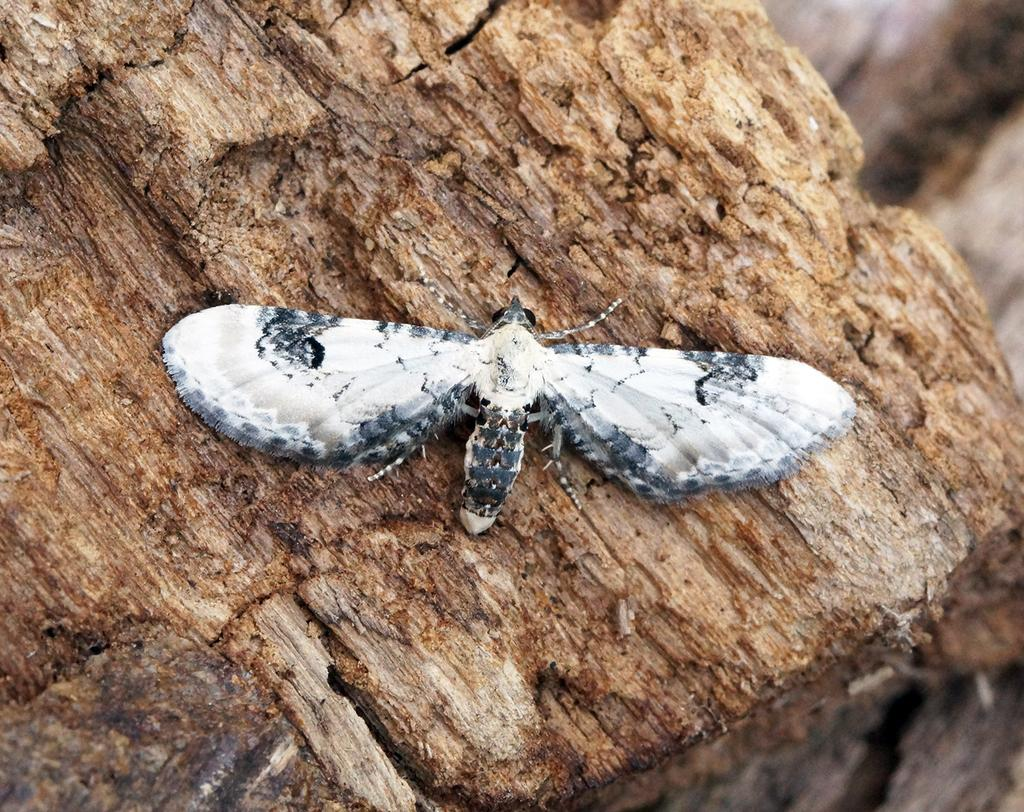What type of creature can be seen in the image? There is an insect in the image. What surface is the insect on? The insect is on a wooden surface. Can you describe the background of the image? The background of the image is blurred. How many frogs can be seen hopping on the hill in the image? There are no frogs or hills present in the image; it features an insect on a wooden surface with a blurred background. 